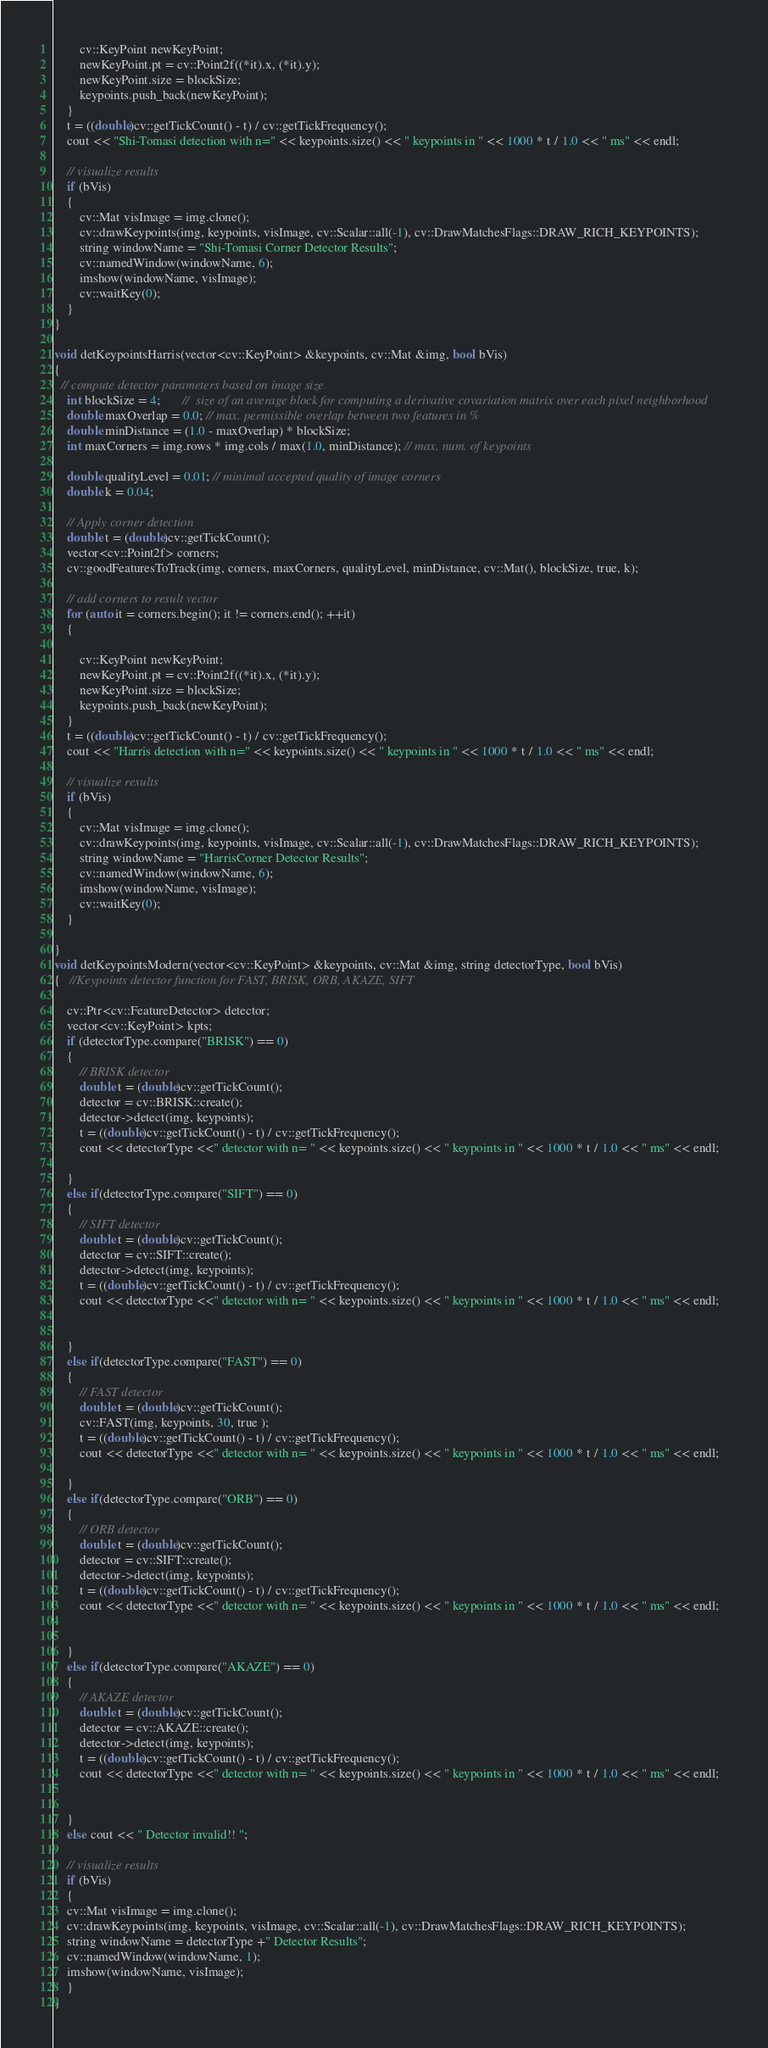Convert code to text. <code><loc_0><loc_0><loc_500><loc_500><_C++_>
        cv::KeyPoint newKeyPoint;
        newKeyPoint.pt = cv::Point2f((*it).x, (*it).y);
        newKeyPoint.size = blockSize;
        keypoints.push_back(newKeyPoint);
    }
    t = ((double)cv::getTickCount() - t) / cv::getTickFrequency();
    cout << "Shi-Tomasi detection with n=" << keypoints.size() << " keypoints in " << 1000 * t / 1.0 << " ms" << endl;

    // visualize results
    if (bVis)
    {
        cv::Mat visImage = img.clone();
        cv::drawKeypoints(img, keypoints, visImage, cv::Scalar::all(-1), cv::DrawMatchesFlags::DRAW_RICH_KEYPOINTS);
        string windowName = "Shi-Tomasi Corner Detector Results";
        cv::namedWindow(windowName, 6);
        imshow(windowName, visImage);
        cv::waitKey(0);
    }
}

void detKeypointsHarris(vector<cv::KeyPoint> &keypoints, cv::Mat &img, bool bVis)
{
  // compute detector parameters based on image size
    int blockSize = 4;       //  size of an average block for computing a derivative covariation matrix over each pixel neighborhood
    double maxOverlap = 0.0; // max. permissible overlap between two features in %
    double minDistance = (1.0 - maxOverlap) * blockSize;
    int maxCorners = img.rows * img.cols / max(1.0, minDistance); // max. num. of keypoints

    double qualityLevel = 0.01; // minimal accepted quality of image corners
    double k = 0.04;

    // Apply corner detection
    double t = (double)cv::getTickCount();
    vector<cv::Point2f> corners;
    cv::goodFeaturesToTrack(img, corners, maxCorners, qualityLevel, minDistance, cv::Mat(), blockSize, true, k);

    // add corners to result vector
    for (auto it = corners.begin(); it != corners.end(); ++it)
    {

        cv::KeyPoint newKeyPoint;
        newKeyPoint.pt = cv::Point2f((*it).x, (*it).y);
        newKeyPoint.size = blockSize;
        keypoints.push_back(newKeyPoint);
    }
    t = ((double)cv::getTickCount() - t) / cv::getTickFrequency();
    cout << "Harris detection with n=" << keypoints.size() << " keypoints in " << 1000 * t / 1.0 << " ms" << endl;

    // visualize results
    if (bVis)
    {
        cv::Mat visImage = img.clone();
        cv::drawKeypoints(img, keypoints, visImage, cv::Scalar::all(-1), cv::DrawMatchesFlags::DRAW_RICH_KEYPOINTS);
        string windowName = "HarrisCorner Detector Results";
        cv::namedWindow(windowName, 6);
        imshow(windowName, visImage);
        cv::waitKey(0);
    }

}
void detKeypointsModern(vector<cv::KeyPoint> &keypoints, cv::Mat &img, string detectorType, bool bVis)
{   //Keypoints detector function for FAST, BRISK, ORB, AKAZE, SIFT
    
    cv::Ptr<cv::FeatureDetector> detector;
    vector<cv::KeyPoint> kpts;
    if (detectorType.compare("BRISK") == 0)
    {   
        // BRISK detector 
        double t = (double)cv::getTickCount();
        detector = cv::BRISK::create();
        detector->detect(img, keypoints);
        t = ((double)cv::getTickCount() - t) / cv::getTickFrequency();
        cout << detectorType <<" detector with n= " << keypoints.size() << " keypoints in " << 1000 * t / 1.0 << " ms" << endl;   

    }
    else if(detectorType.compare("SIFT") == 0) 
    {   
        // SIFT detector
        double t = (double)cv::getTickCount();
        detector = cv::SIFT::create();
        detector->detect(img, keypoints);
        t = ((double)cv::getTickCount() - t) / cv::getTickFrequency();
        cout << detectorType <<" detector with n= " << keypoints.size() << " keypoints in " << 1000 * t / 1.0 << " ms" << endl;   


    }
    else if(detectorType.compare("FAST") == 0) 
    {   
        // FAST detector
        double t = (double)cv::getTickCount();
        cv::FAST(img, keypoints, 30, true );
        t = ((double)cv::getTickCount() - t) / cv::getTickFrequency();
        cout << detectorType <<" detector with n= " << keypoints.size() << " keypoints in " << 1000 * t / 1.0 << " ms" << endl;   

    }
    else if(detectorType.compare("ORB") == 0) 
    {   
        // ORB detector
        double t = (double)cv::getTickCount();
        detector = cv::SIFT::create();
        detector->detect(img, keypoints);
        t = ((double)cv::getTickCount() - t) / cv::getTickFrequency();
        cout << detectorType <<" detector with n= " << keypoints.size() << " keypoints in " << 1000 * t / 1.0 << " ms" << endl;   


    }
    else if(detectorType.compare("AKAZE") == 0) 
    {   
        // AKAZE detector
        double t = (double)cv::getTickCount();
        detector = cv::AKAZE::create();
        detector->detect(img, keypoints);
        t = ((double)cv::getTickCount() - t) / cv::getTickFrequency();
        cout << detectorType <<" detector with n= " << keypoints.size() << " keypoints in " << 1000 * t / 1.0 << " ms" << endl;   


    }
    else cout << " Detector invalid!! ";

    // visualize results
    if (bVis)
    {
    cv::Mat visImage = img.clone();
    cv::drawKeypoints(img, keypoints, visImage, cv::Scalar::all(-1), cv::DrawMatchesFlags::DRAW_RICH_KEYPOINTS);
    string windowName = detectorType +" Detector Results";
    cv::namedWindow(windowName, 1);
    imshow(windowName, visImage);
    }
}
</code> 